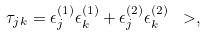Convert formula to latex. <formula><loc_0><loc_0><loc_500><loc_500>\tau _ { j k } = \epsilon ^ { ( 1 ) } _ { j } \epsilon ^ { ( 1 ) } _ { k } + \epsilon ^ { ( 2 ) } _ { j } \epsilon ^ { ( 2 ) } _ { k } \ > ,</formula> 